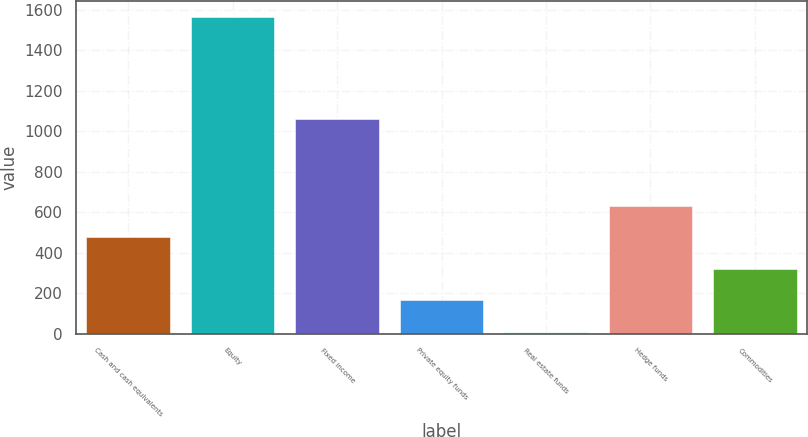<chart> <loc_0><loc_0><loc_500><loc_500><bar_chart><fcel>Cash and cash equivalents<fcel>Equity<fcel>Fixed income<fcel>Private equity funds<fcel>Real estate funds<fcel>Hedge funds<fcel>Commodities<nl><fcel>476.5<fcel>1565<fcel>1060<fcel>165.5<fcel>10<fcel>632<fcel>321<nl></chart> 